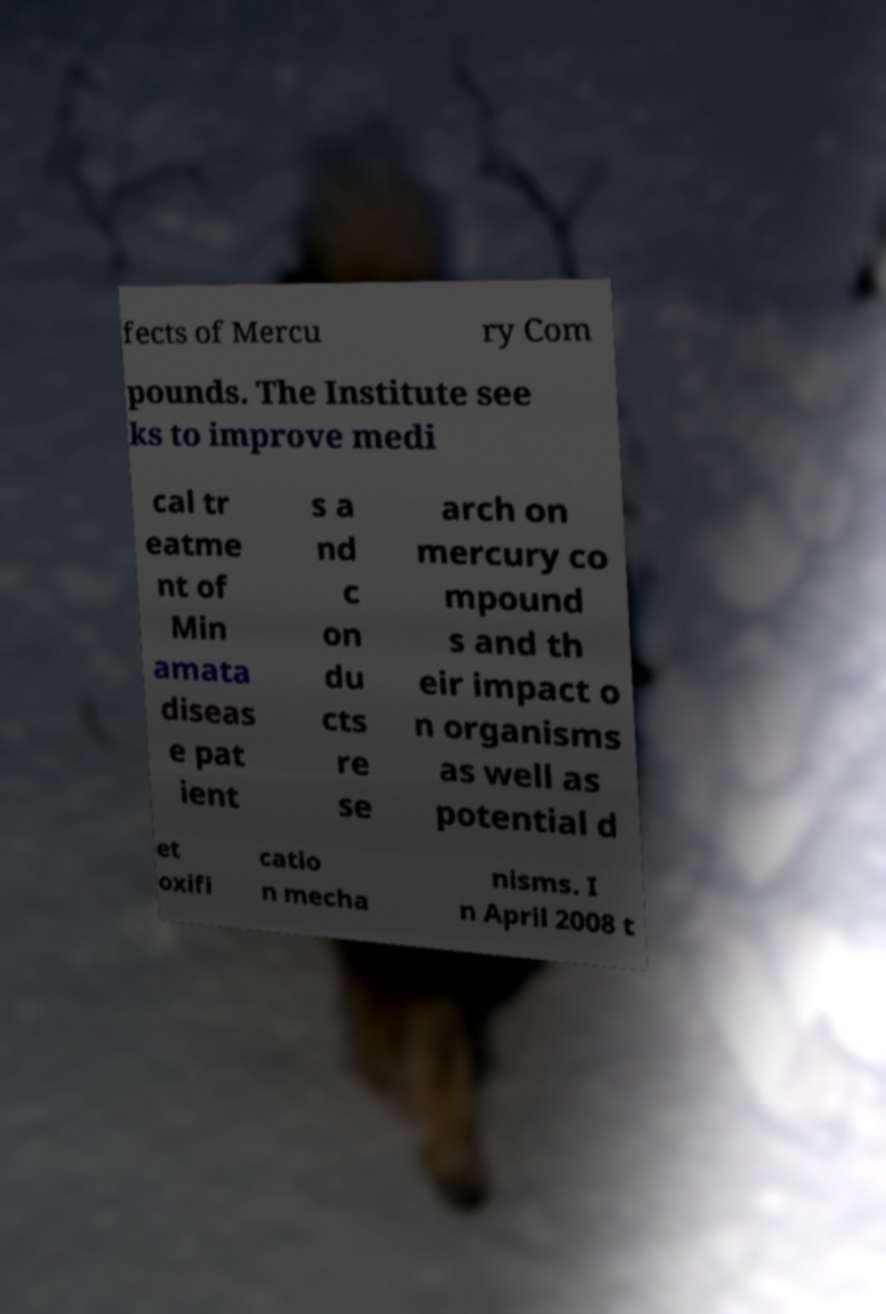Please read and relay the text visible in this image. What does it say? fects of Mercu ry Com pounds. The Institute see ks to improve medi cal tr eatme nt of Min amata diseas e pat ient s a nd c on du cts re se arch on mercury co mpound s and th eir impact o n organisms as well as potential d et oxifi catio n mecha nisms. I n April 2008 t 